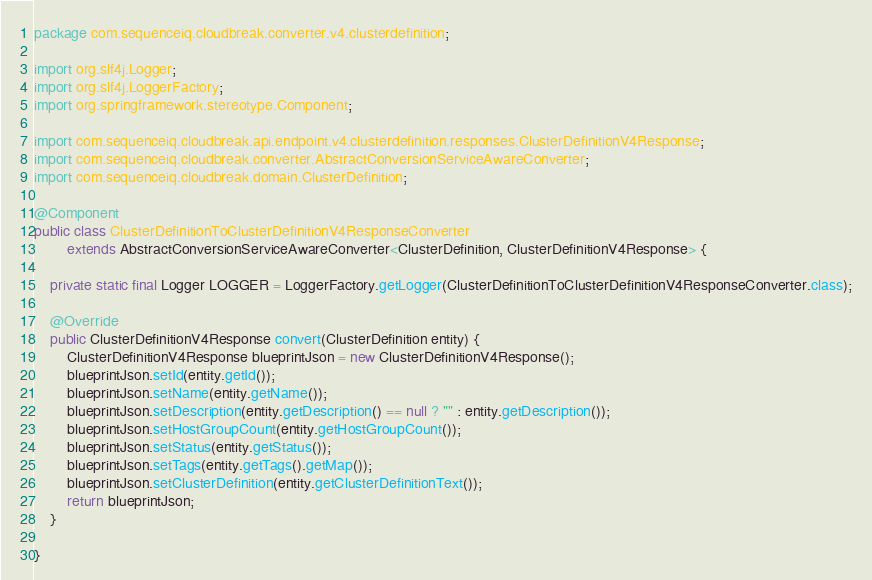<code> <loc_0><loc_0><loc_500><loc_500><_Java_>package com.sequenceiq.cloudbreak.converter.v4.clusterdefinition;

import org.slf4j.Logger;
import org.slf4j.LoggerFactory;
import org.springframework.stereotype.Component;

import com.sequenceiq.cloudbreak.api.endpoint.v4.clusterdefinition.responses.ClusterDefinitionV4Response;
import com.sequenceiq.cloudbreak.converter.AbstractConversionServiceAwareConverter;
import com.sequenceiq.cloudbreak.domain.ClusterDefinition;

@Component
public class ClusterDefinitionToClusterDefinitionV4ResponseConverter
        extends AbstractConversionServiceAwareConverter<ClusterDefinition, ClusterDefinitionV4Response> {

    private static final Logger LOGGER = LoggerFactory.getLogger(ClusterDefinitionToClusterDefinitionV4ResponseConverter.class);

    @Override
    public ClusterDefinitionV4Response convert(ClusterDefinition entity) {
        ClusterDefinitionV4Response blueprintJson = new ClusterDefinitionV4Response();
        blueprintJson.setId(entity.getId());
        blueprintJson.setName(entity.getName());
        blueprintJson.setDescription(entity.getDescription() == null ? "" : entity.getDescription());
        blueprintJson.setHostGroupCount(entity.getHostGroupCount());
        blueprintJson.setStatus(entity.getStatus());
        blueprintJson.setTags(entity.getTags().getMap());
        blueprintJson.setClusterDefinition(entity.getClusterDefinitionText());
        return blueprintJson;
    }

}
</code> 